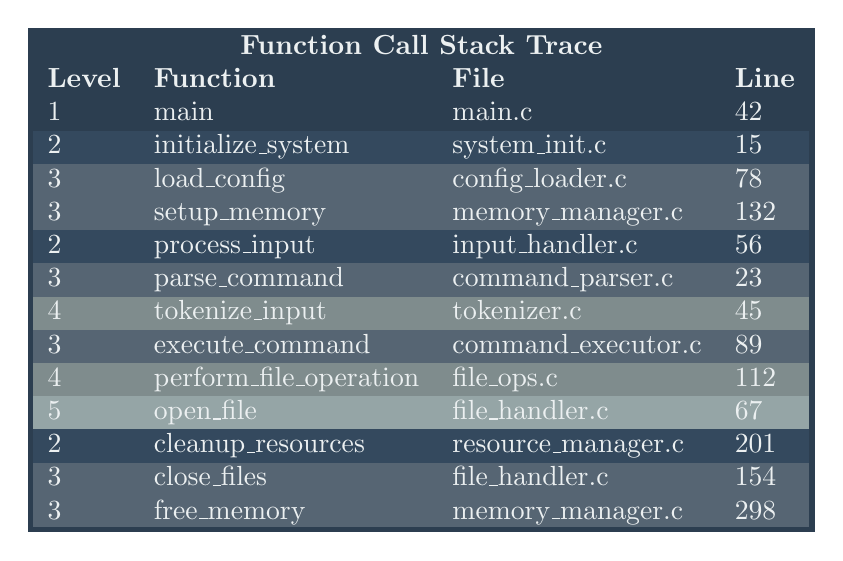What is the function at level 3 that is called after 'initialize_system'? After 'initialize_system' (level 2), the next function listed is 'process_input', which is at level 2. Within 'process_input', the functions at level 3 are 'parse_command' and 'execute_command'. Therefore, the first function at level 3 called after 'initialize_system' is 'parse_command'.
Answer: parse_command How many functions are at level 4? Looking at the table, there are two functions at level 4: 'tokenize_input' and 'perform_file_operation'. Thus, the total count of functions at level 4 is 2.
Answer: 2 What file does the function 'cleanup_resources' originate from? The table lists the function 'cleanup_resources' under the column for the File, which shows 'resource_manager.c'. Thus, the file that contains this function is identified.
Answer: resource_manager.c Is the function 'open_file' at a lower level than 'load_config'? Based on the hierarchy in the table, 'open_file' is at level 5, whereas 'load_config' is at level 3. Since 5 is greater than 3, this indicates that 'open_file' is indeed at a lower level than 'load_config'.
Answer: Yes Which function has the highest line number associated with it? By reviewing the 'Line' column in the table, we find 'free_memory' has the highest line number, which is 298. Therefore, this is the function with the highest line number.
Answer: free_memory Count the total number of functions listed in the trace. To find the total number of functions, we add up each level: 1 function at level 1 (main), 3 at level 2 (initialize_system, process_input, cleanup_resources), 4 at level 3 (load_config, setup_memory, parse_command, execute_command), 2 at level 4 (tokenize_input, perform_file_operation), and 1 at level 5 (open_file). Summing these gives 1 + 3 + 4 + 2 + 1 = 11 functions total.
Answer: 11 If 'perform_file_operation' fails, which function would directly handle the error next? The table shows that 'perform_file_operation' is called by 'execute_command', which is nested within 'process_input'. Thus, in the event of a failure in 'perform_file_operation', the next function that would handle it is 'execute_command'.
Answer: execute_command 